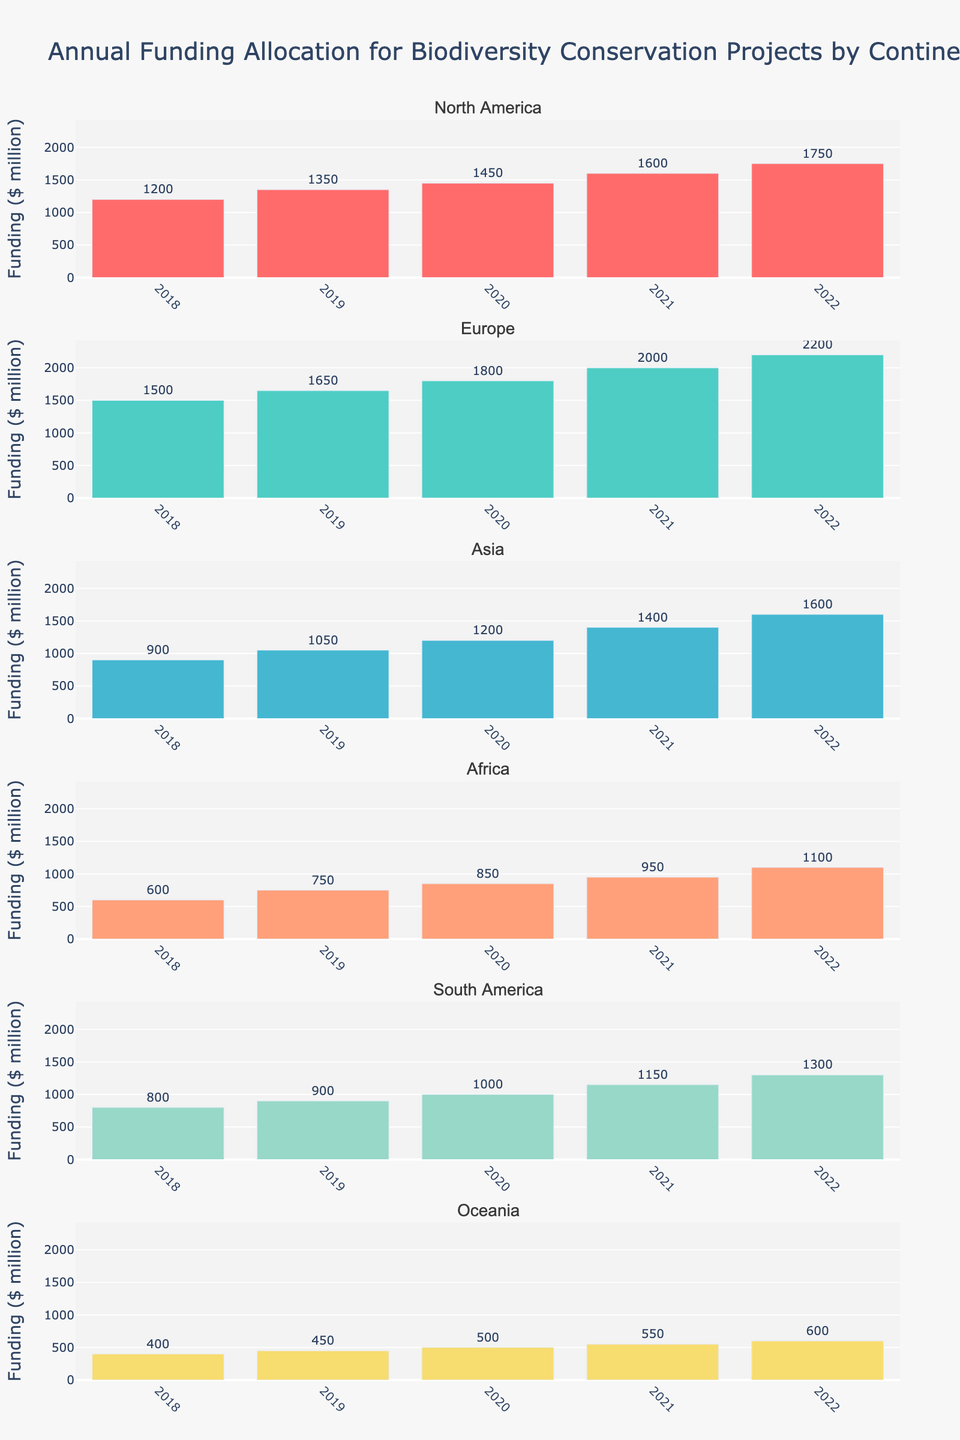what is the highest cost for Educational Software? To find the highest cost for Educational Software, look at the bars labeled for each education stage. The tallest bar represents the highest cost. For Educational Software, the highest bar is in the Advanced Placement stage. The y-axis shows the cost as $250.
Answer: $250 what is the total cost for Textbooks in all education stages combined? Add up the values for Textbooks across all education stages from the figure. For Elementary is $250, Middle School is $350, High School is $450, and Advanced Placement is $550. Sum them up: $250 + $350 + $450 + $550.
Answer: $1600 which stage has the lowest cost for Field Trips and what is the amount? Look at the Field Trips category for each education stage and identify the shortest bar. The Elementary stage has the shortest bar for Field Trips, showing a cost of $100.
Answer: Elementary, $100 compare the total costs of Supplies and Online Courses for Elementary stage. Which one is higher and by how much? Check the bars for Supplies and Online Courses in the Elementary stage. Supplies cost $200 and Online Courses cost $150. Compare the two values: $200 - $150 = $50.
Answer: Supplies, $50 what is the difference in Curriculum Packages cost between High School and Middle School? Identify the Curriculum Packages costs for both High School and Middle School from the figure. High School is $600 and Middle School is $500. Subtract the two values: $600 - $500.
Answer: $100 what has the highest overall cost among all resource types and in which stage? To find the highest overall cost, look at the tallest bar in the entire figure. The tallest bar is for Curriculum Packages in the Advanced Placement stage, showing $700.
Answer: Curriculum Packages, Advanced Placement what is the average cost of Online Courses across all education stages? Identify the cost of Online Courses for each stage and add them: Elementary $150, Middle School $200, High School $300, Advanced Placement $400. Sum these values and divide by the number of stages: ($150 + $200 + $300 + $400) / 4.
Answer: $262.50 which resource type shows a consistent increase in cost across all education stages? Inspect each bar corresponding to each resource type and see if it increases consistently from Elementary to Advanced Placement. Textbooks show an increasing pattern: $250, $350, $450, $550.
Answer: Textbooks what is the total cost difference between Elementary and Advanced Placement stages for all resource types combined? Sum the costs for all resource types in both Elementary and Advanced Placement stages. Elementary: $250 + $150 + $100 + $200 + $100 + $400 = $1200. Advanced Placement: $550 + $400 + $250 + $350 + $250 + $700 = $2500. Subtract the two totals: $2500 - $1200.
Answer: $1300 